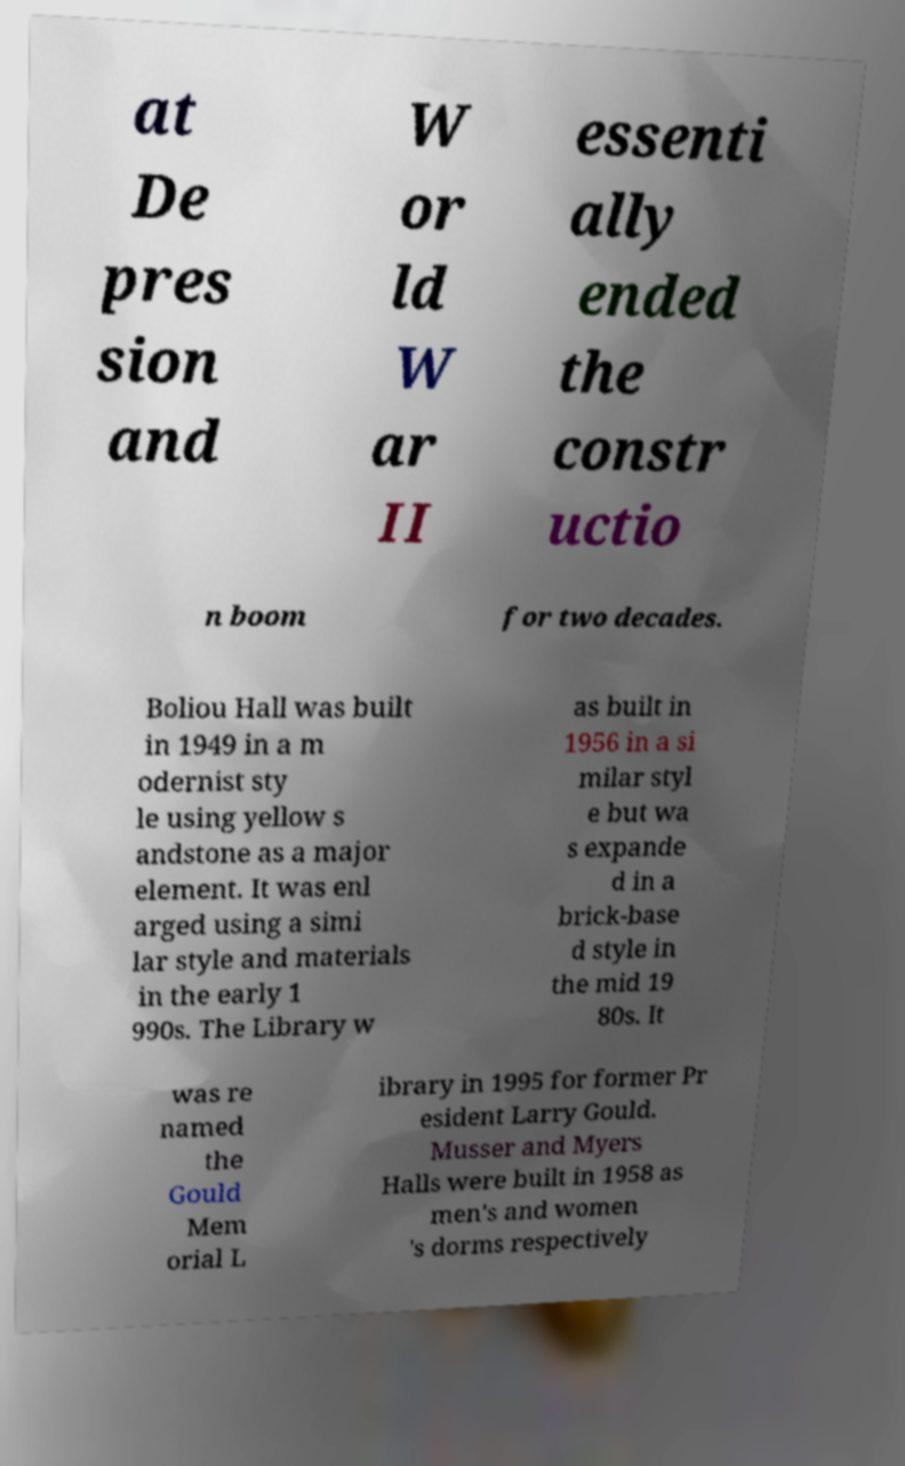Could you assist in decoding the text presented in this image and type it out clearly? at De pres sion and W or ld W ar II essenti ally ended the constr uctio n boom for two decades. Boliou Hall was built in 1949 in a m odernist sty le using yellow s andstone as a major element. It was enl arged using a simi lar style and materials in the early 1 990s. The Library w as built in 1956 in a si milar styl e but wa s expande d in a brick-base d style in the mid 19 80s. It was re named the Gould Mem orial L ibrary in 1995 for former Pr esident Larry Gould. Musser and Myers Halls were built in 1958 as men's and women 's dorms respectively 